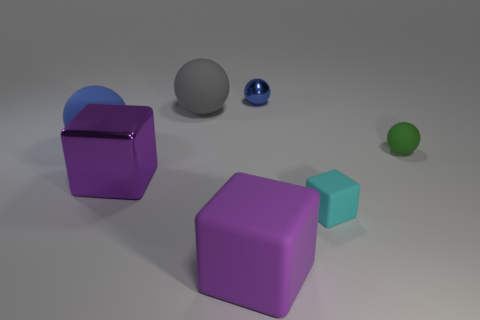Subtract all green cylinders. How many purple cubes are left? 2 Add 1 purple metal things. How many objects exist? 8 Subtract all matte blocks. How many blocks are left? 1 Subtract 1 spheres. How many spheres are left? 3 Subtract all cubes. How many objects are left? 4 Subtract all gray spheres. How many spheres are left? 3 Add 1 small metal things. How many small metal things are left? 2 Add 7 big gray rubber spheres. How many big gray rubber spheres exist? 8 Subtract 0 red cylinders. How many objects are left? 7 Subtract all cyan spheres. Subtract all gray cylinders. How many spheres are left? 4 